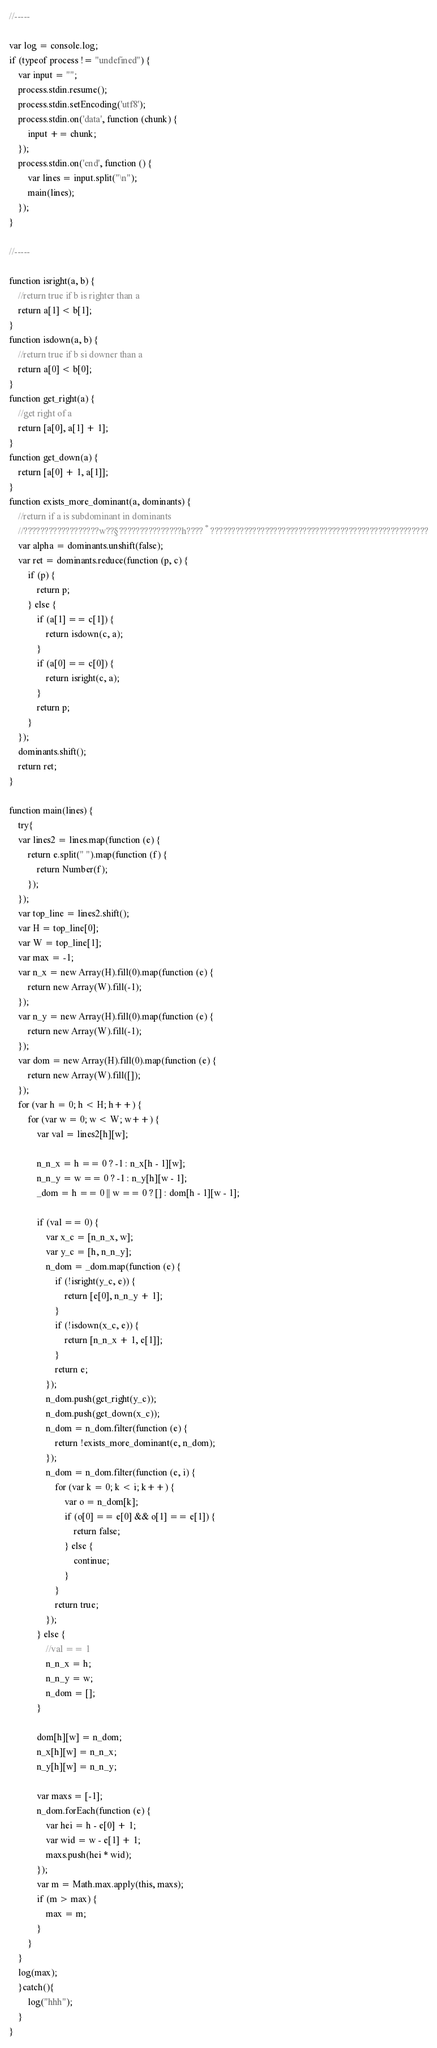<code> <loc_0><loc_0><loc_500><loc_500><_JavaScript_>//-----

var log = console.log;
if (typeof process != "undefined") {
	var input = "";
	process.stdin.resume();
	process.stdin.setEncoding('utf8');
	process.stdin.on('data', function (chunk) {
		input += chunk;
	});
	process.stdin.on('end', function () {
		var lines = input.split("\n");
		main(lines);
	});
}

//-----

function isright(a, b) {
	//return true if b is righter than a
	return a[1] < b[1];
}
function isdown(a, b) {
	//return true if b si downer than a
	return a[0] < b[0];
}
function get_right(a) {
	//get right of a
	return [a[0], a[1] + 1];
}
function get_down(a) {
	return [a[0] + 1, a[1]];
}
function exists_more_dominant(a, dominants) {
	//return if a is subdominant in dominants
	//??????????????????w??§???????????????h????°????????????????????????????????????????????????????
	var alpha = dominants.unshift(false);
	var ret = dominants.reduce(function (p, c) {
		if (p) {
			return p;
		} else {
			if (a[1] == c[1]) {
				return isdown(c, a);
			}
			if (a[0] == c[0]) {
				return isright(c, a);
			}
			return p;
		}
	});
	dominants.shift();
	return ret;
}

function main(lines) {
	try{
	var lines2 = lines.map(function (e) {
		return e.split(" ").map(function (f) {
			return Number(f);
		});
	});
	var top_line = lines2.shift();
	var H = top_line[0];
	var W = top_line[1];
	var max = -1;
	var n_x = new Array(H).fill(0).map(function (e) {
		return new Array(W).fill(-1);
	});
	var n_y = new Array(H).fill(0).map(function (e) {
		return new Array(W).fill(-1);
	});
	var dom = new Array(H).fill(0).map(function (e) {
		return new Array(W).fill([]);
	});
	for (var h = 0; h < H; h++) {
		for (var w = 0; w < W; w++) {
			var val = lines2[h][w];

			n_n_x = h == 0 ? -1 : n_x[h - 1][w];
			n_n_y = w == 0 ? -1 : n_y[h][w - 1];
			_dom = h == 0 || w == 0 ? [] : dom[h - 1][w - 1];

			if (val == 0) {
				var x_c = [n_n_x, w];
				var y_c = [h, n_n_y];
				n_dom = _dom.map(function (e) {
					if (!isright(y_c, e)) {
						return [e[0], n_n_y + 1];
					}
					if (!isdown(x_c, e)) {
						return [n_n_x + 1, e[1]];
					}
					return e;
				});
				n_dom.push(get_right(y_c));
				n_dom.push(get_down(x_c));
				n_dom = n_dom.filter(function (e) {
					return !exists_more_dominant(e, n_dom);
				});
				n_dom = n_dom.filter(function (e, i) {
					for (var k = 0; k < i; k++) {
						var o = n_dom[k];
						if (o[0] == e[0] && o[1] == e[1]) {
							return false;
						} else {
							continue;
						}
					}
					return true;
				});
			} else {
				//val == 1
				n_n_x = h;
				n_n_y = w;
				n_dom = [];
			}

			dom[h][w] = n_dom;
			n_x[h][w] = n_n_x;
			n_y[h][w] = n_n_y;

			var maxs = [-1];
			n_dom.forEach(function (e) {
				var hei = h - e[0] + 1;
				var wid = w - e[1] + 1;
				maxs.push(hei * wid);
			});
			var m = Math.max.apply(this, maxs);
			if (m > max) {
				max = m;
			}
		}
	}
	log(max);
	}catch(){
		log("hhh");
	}
}</code> 